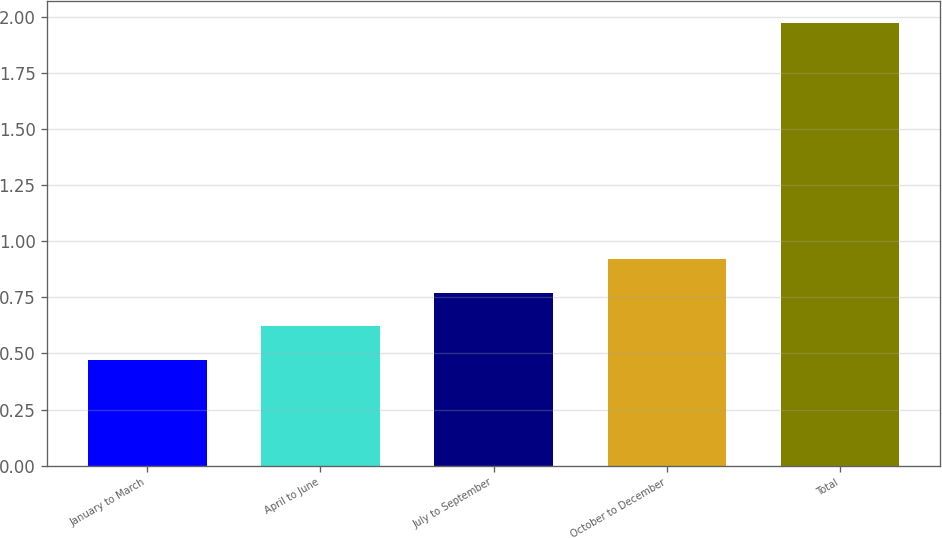Convert chart to OTSL. <chart><loc_0><loc_0><loc_500><loc_500><bar_chart><fcel>January to March<fcel>April to June<fcel>July to September<fcel>October to December<fcel>Total<nl><fcel>0.47<fcel>0.62<fcel>0.77<fcel>0.92<fcel>1.97<nl></chart> 